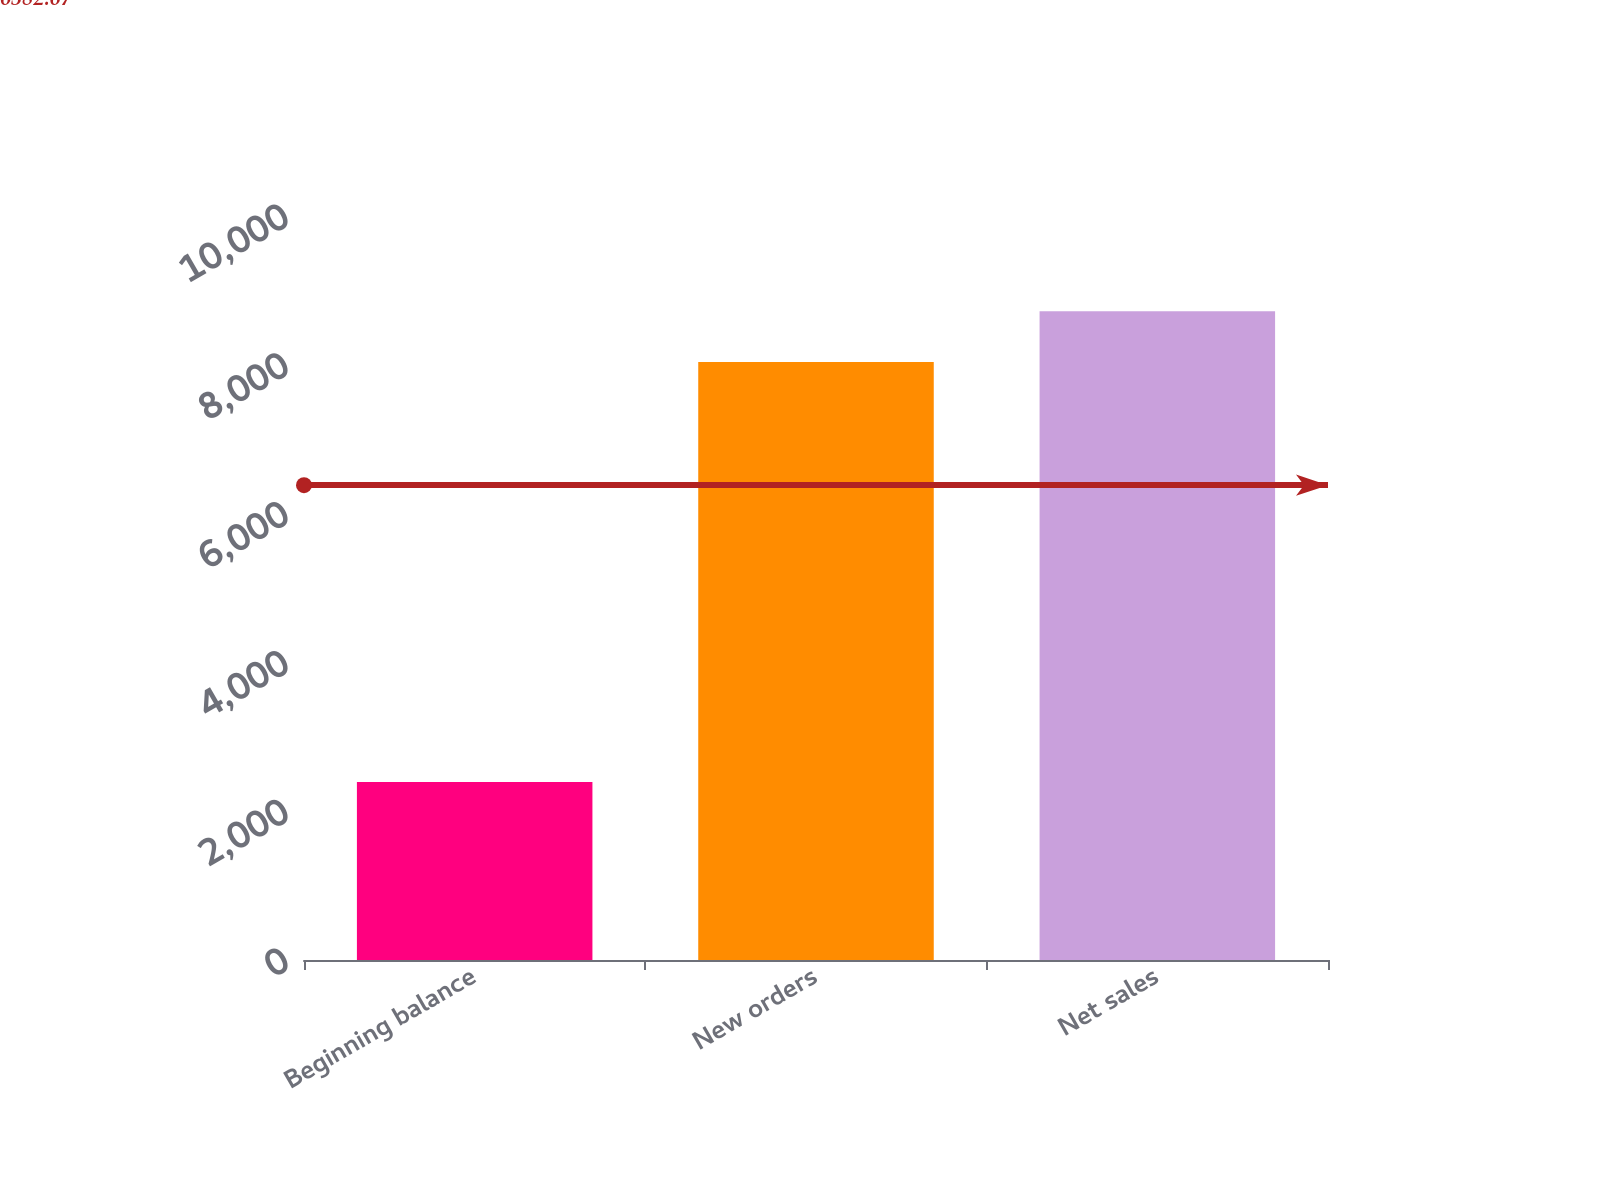Convert chart to OTSL. <chart><loc_0><loc_0><loc_500><loc_500><bar_chart><fcel>Beginning balance<fcel>New orders<fcel>Net sales<nl><fcel>2392<fcel>8037<fcel>8719<nl></chart> 